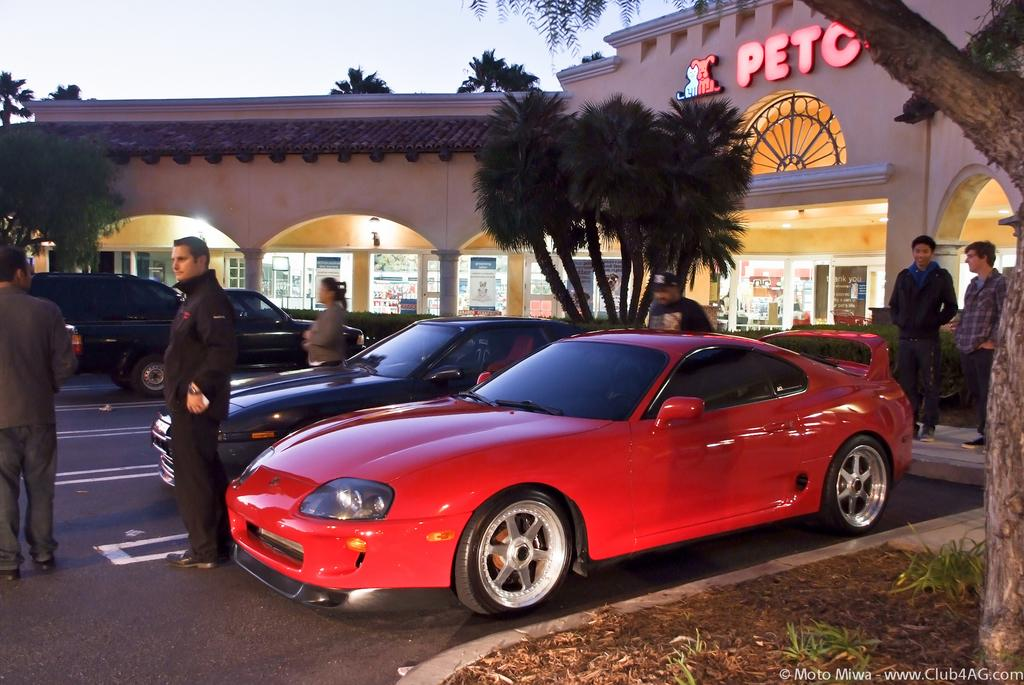How many cars are present in the image? There are two cars in the image. What is the location of the cars in relation to the store? The cars are in front of a store. What can be seen behind the cars in the image? There are trees visible behind the cars. Are there any people present in the image? Yes, there are people standing in the image. What is visible above the scene in the image? The sky is visible above the scene. What type of bath is being prepared for the cars in the image? There is no indication in the image that a bath is being prepared for the cars. 